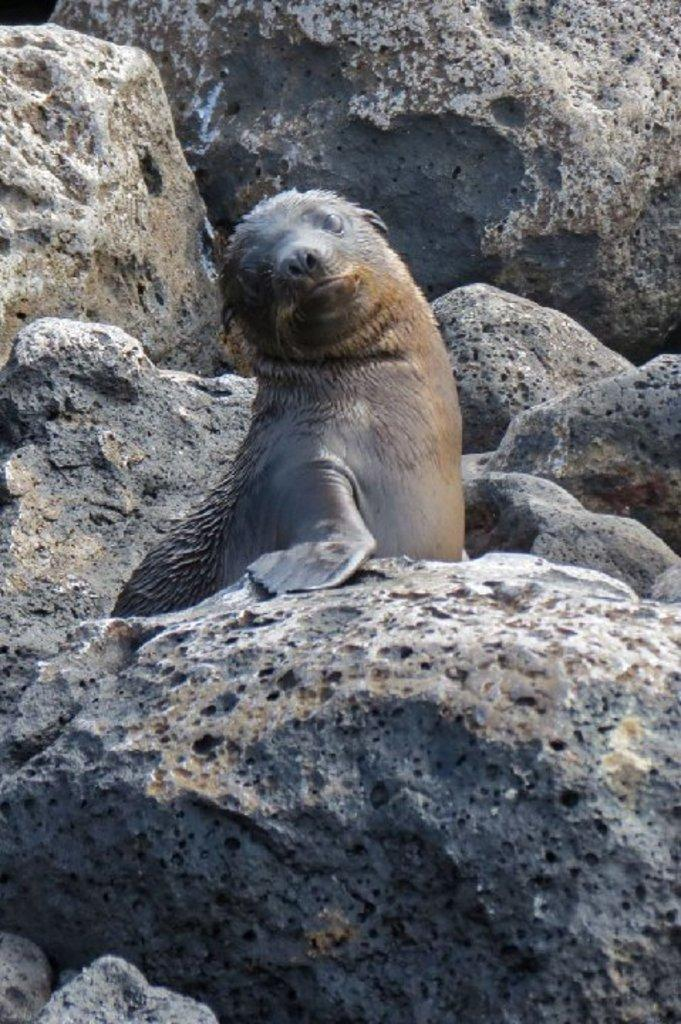What type of objects can be seen in the image? There are stones in the image. Can you describe any animals present in the image? There is a black-colored seal in the image. How many rabbits are involved in the fight in the image? There are no rabbits or fights present in the image; it features stones and a black-colored seal. 